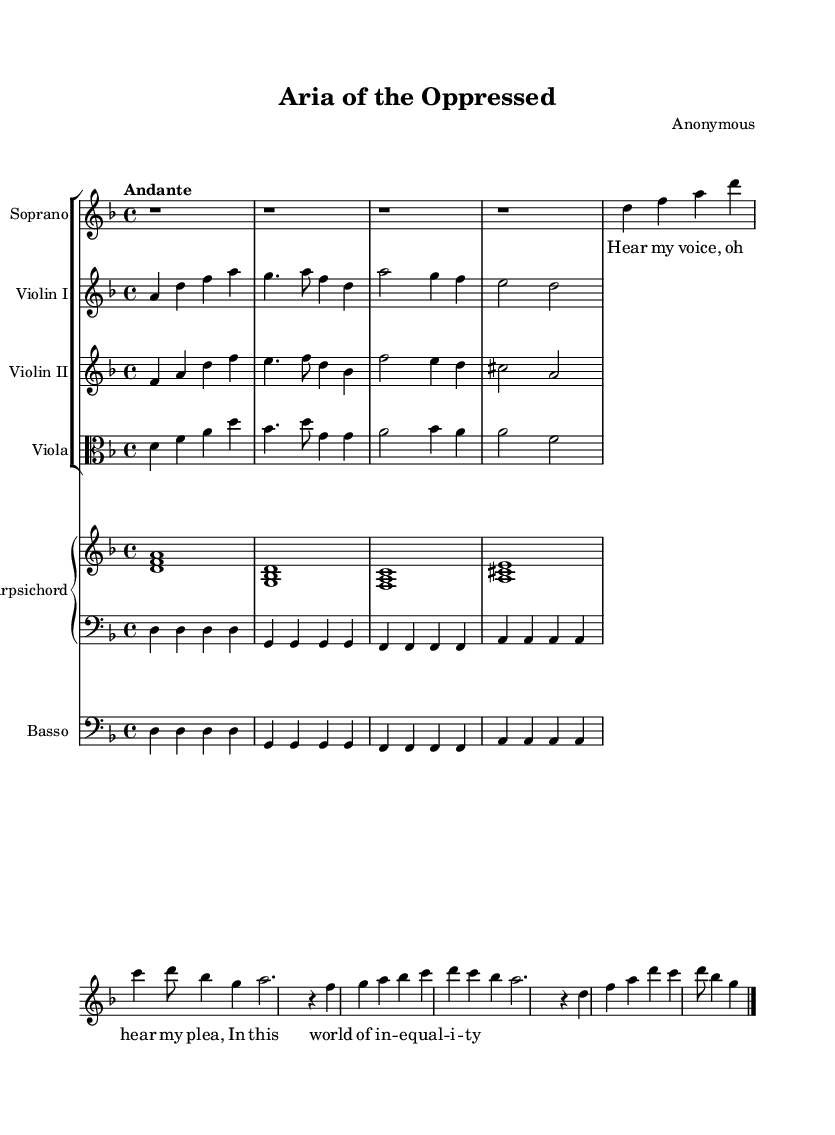What is the key signature of this music? The key signature has two flats, indicating that it is in D minor. This can be identified by looking at the key signature at the beginning of the piece.
Answer: D minor What is the time signature of this music? The time signature is indicated at the beginning of the score and shows 4/4, which means there are four beats in each measure.
Answer: 4/4 What is the tempo marking of this music? The tempo marking is "Andante," which suggests a moderate pace for the piece. This is typically found at the beginning of the score, indicating how the piece should be played.
Answer: Andante How many measures are in the A section of the aria? The A section consists of 8 measures. By counting the measures in the soprano part, it is evident that the A section does not follow the typical 16 measures found in many arias.
Answer: 8 measures What instruments are included in this composition? The composition features a soprano voice, two violins, a viola, a basso, and a harpsichord. This can be deduced from the different staves listed in the score, each assigned to a specific instrument.
Answer: Soprano, Violin I, Violin II, Viola, Basso, Harpsichord What theme does the soprano's lyrics address in this aria? The lyrics express a plea for recognition and voice in the context of social inequality. This theme resonates with the title and suggests a focus on social issues relevant to 17th-century society.
Answer: Social inequality 